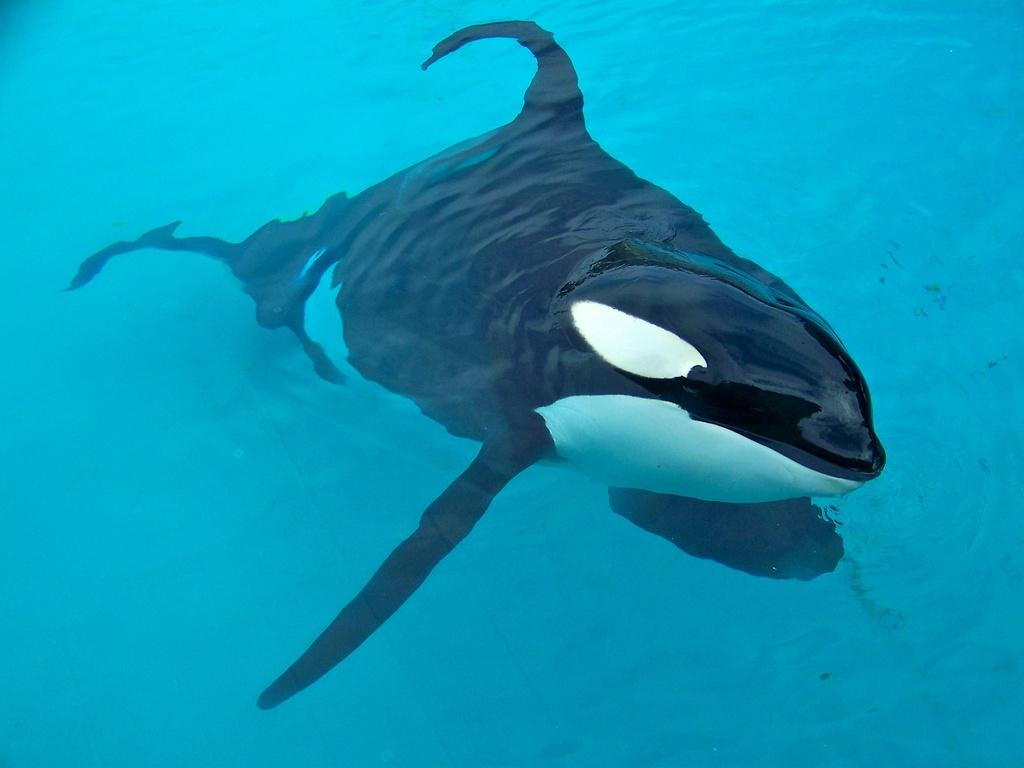What type of animal is in the water in the image? There is a killer whale in the water. Can you describe the environment in which the animal is located? The killer whale is in the water. What is the thumb doing in the image? There is no thumb present in the image. Can you describe the frog's behavior in the image? There is no frog present in the image. 